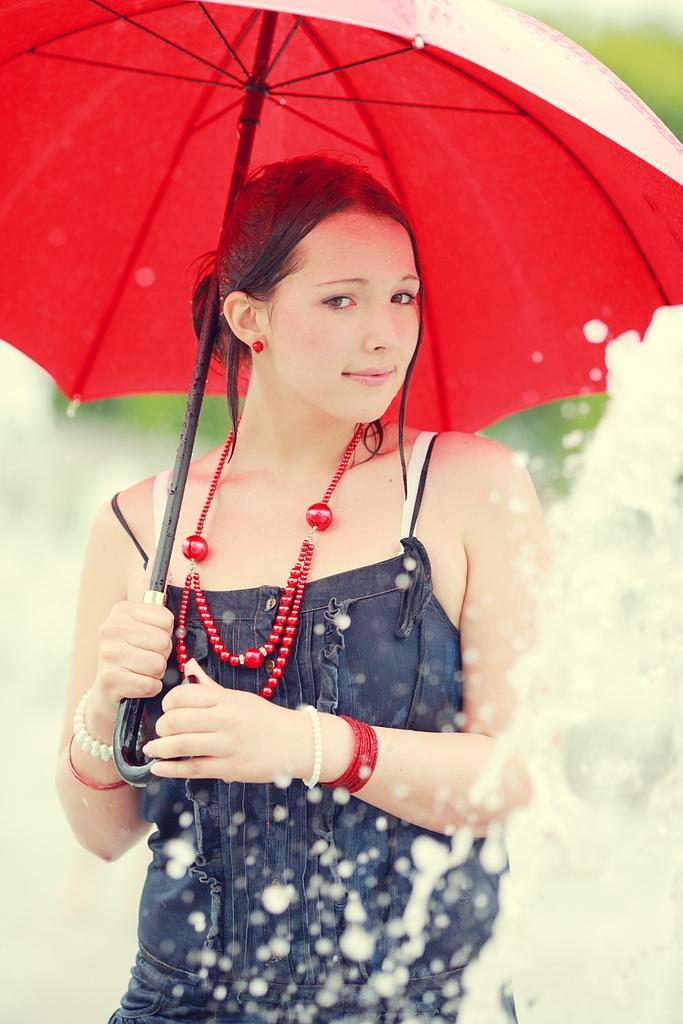Who is present in the image? There is a lady in the image. What is the lady holding in the image? The lady is holding an umbrella. What can be seen in the image besides the lady? There is water visible in the image. Can you describe the background of the image? The background of the image is blurred. What type of store can be seen in the background of the image? There is no store visible in the background of the image; the background is blurred. What type of learning material is the lady using in the image? There is no learning material present in the image; the lady is holding an umbrella. 